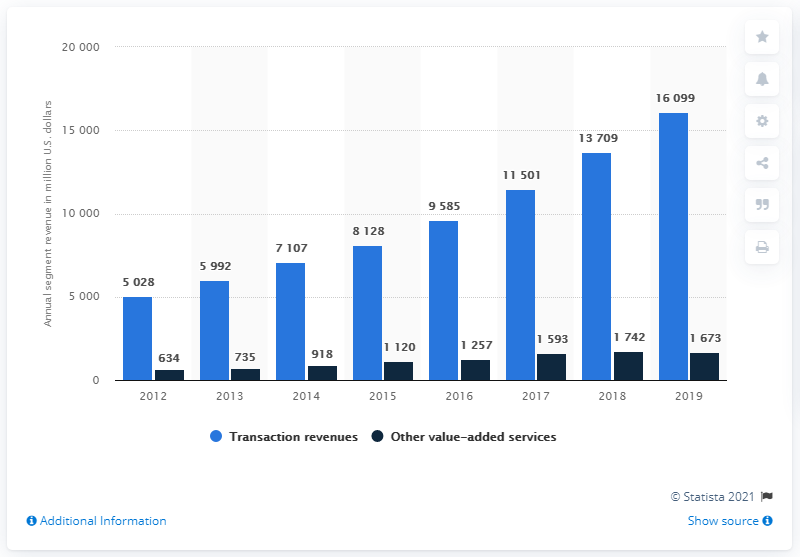How many dollars did other value-added services generate in revenue in 2019? In 2019, revenue generated from other value-added services amounted to $1,673 million, according to the data presented in the bar chart. 